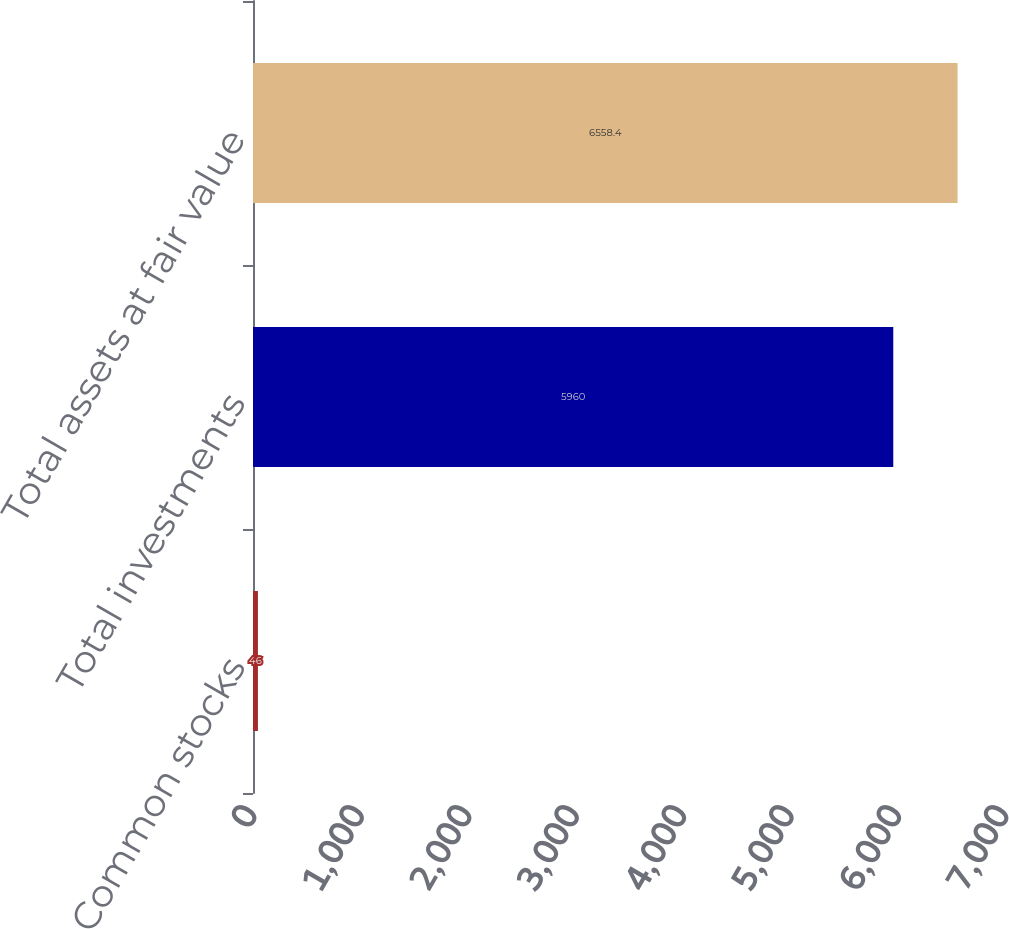Convert chart to OTSL. <chart><loc_0><loc_0><loc_500><loc_500><bar_chart><fcel>Common stocks<fcel>Total investments<fcel>Total assets at fair value<nl><fcel>46<fcel>5960<fcel>6558.4<nl></chart> 